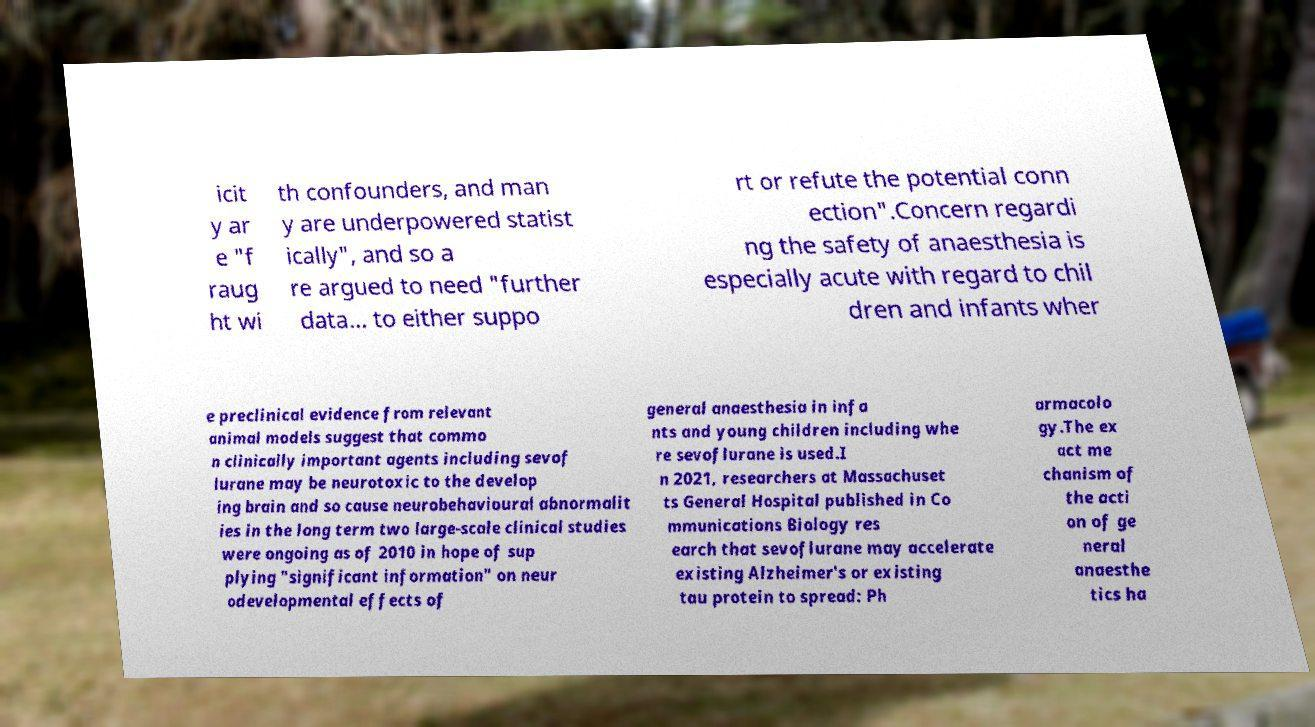Can you accurately transcribe the text from the provided image for me? icit y ar e "f raug ht wi th confounders, and man y are underpowered statist ically", and so a re argued to need "further data... to either suppo rt or refute the potential conn ection".Concern regardi ng the safety of anaesthesia is especially acute with regard to chil dren and infants wher e preclinical evidence from relevant animal models suggest that commo n clinically important agents including sevof lurane may be neurotoxic to the develop ing brain and so cause neurobehavioural abnormalit ies in the long term two large-scale clinical studies were ongoing as of 2010 in hope of sup plying "significant information" on neur odevelopmental effects of general anaesthesia in infa nts and young children including whe re sevoflurane is used.I n 2021, researchers at Massachuset ts General Hospital published in Co mmunications Biology res earch that sevoflurane may accelerate existing Alzheimer's or existing tau protein to spread: Ph armacolo gy.The ex act me chanism of the acti on of ge neral anaesthe tics ha 